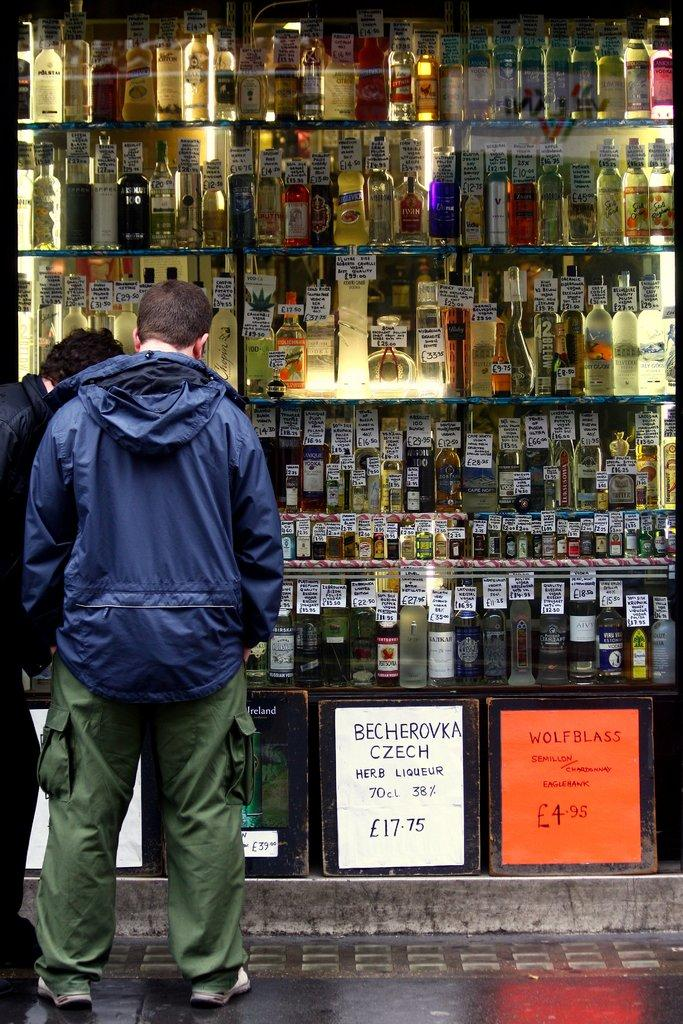<image>
Present a compact description of the photo's key features. Two men looking in the window of a liquor store who are selling Becherovka at 17.75 